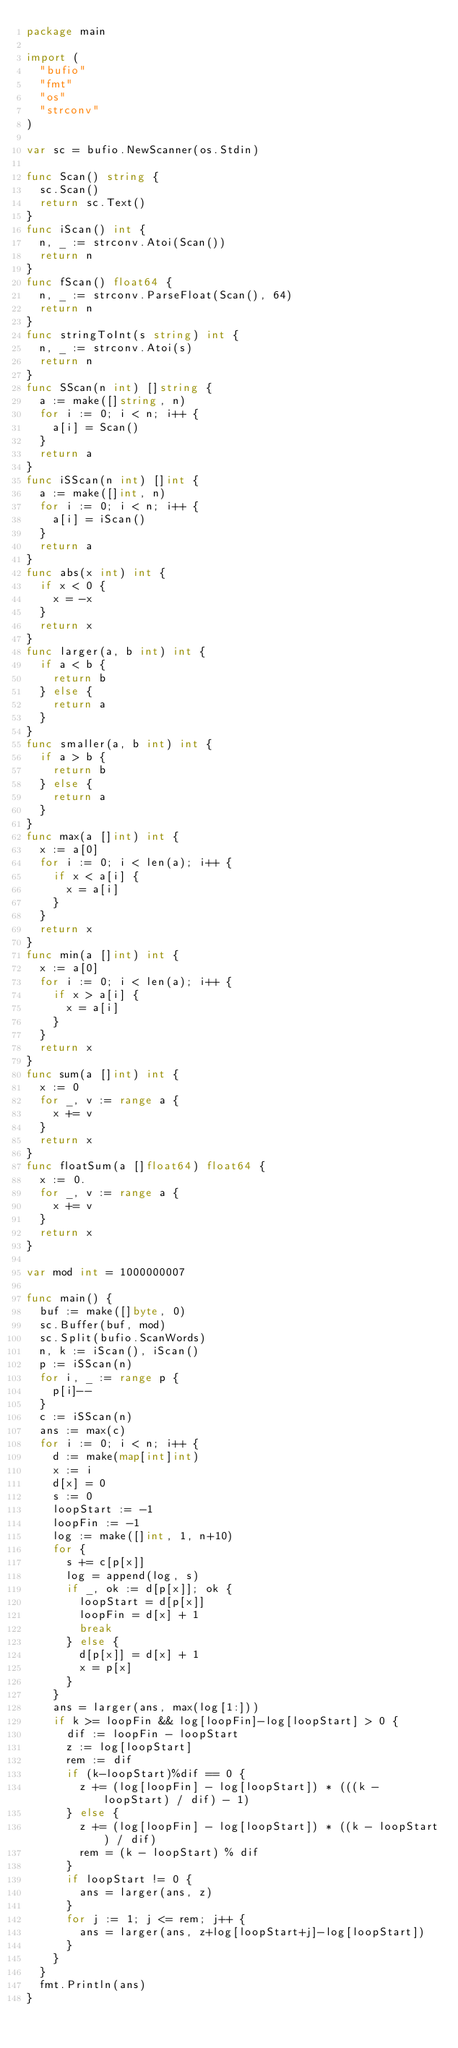<code> <loc_0><loc_0><loc_500><loc_500><_Go_>package main

import (
	"bufio"
	"fmt"
	"os"
	"strconv"
)

var sc = bufio.NewScanner(os.Stdin)

func Scan() string {
	sc.Scan()
	return sc.Text()
}
func iScan() int {
	n, _ := strconv.Atoi(Scan())
	return n
}
func fScan() float64 {
	n, _ := strconv.ParseFloat(Scan(), 64)
	return n
}
func stringToInt(s string) int {
	n, _ := strconv.Atoi(s)
	return n
}
func SScan(n int) []string {
	a := make([]string, n)
	for i := 0; i < n; i++ {
		a[i] = Scan()
	}
	return a
}
func iSScan(n int) []int {
	a := make([]int, n)
	for i := 0; i < n; i++ {
		a[i] = iScan()
	}
	return a
}
func abs(x int) int {
	if x < 0 {
		x = -x
	}
	return x
}
func larger(a, b int) int {
	if a < b {
		return b
	} else {
		return a
	}
}
func smaller(a, b int) int {
	if a > b {
		return b
	} else {
		return a
	}
}
func max(a []int) int {
	x := a[0]
	for i := 0; i < len(a); i++ {
		if x < a[i] {
			x = a[i]
		}
	}
	return x
}
func min(a []int) int {
	x := a[0]
	for i := 0; i < len(a); i++ {
		if x > a[i] {
			x = a[i]
		}
	}
	return x
}
func sum(a []int) int {
	x := 0
	for _, v := range a {
		x += v
	}
	return x
}
func floatSum(a []float64) float64 {
	x := 0.
	for _, v := range a {
		x += v
	}
	return x
}

var mod int = 1000000007

func main() {
	buf := make([]byte, 0)
	sc.Buffer(buf, mod)
	sc.Split(bufio.ScanWords)
	n, k := iScan(), iScan()
	p := iSScan(n)
	for i, _ := range p {
		p[i]--
	}
	c := iSScan(n)
	ans := max(c)
	for i := 0; i < n; i++ {
		d := make(map[int]int)
		x := i
		d[x] = 0
		s := 0
		loopStart := -1
		loopFin := -1
		log := make([]int, 1, n+10)
		for {
			s += c[p[x]]
			log = append(log, s)
			if _, ok := d[p[x]]; ok {
				loopStart = d[p[x]]
				loopFin = d[x] + 1
				break
			} else {
				d[p[x]] = d[x] + 1
				x = p[x]
			}
		}
		ans = larger(ans, max(log[1:]))
		if k >= loopFin && log[loopFin]-log[loopStart] > 0 {
			dif := loopFin - loopStart
			z := log[loopStart]
			rem := dif
			if (k-loopStart)%dif == 0 {
				z += (log[loopFin] - log[loopStart]) * (((k - loopStart) / dif) - 1)
			} else {
				z += (log[loopFin] - log[loopStart]) * ((k - loopStart) / dif)
				rem = (k - loopStart) % dif
			}
			if loopStart != 0 {
				ans = larger(ans, z)
			}
			for j := 1; j <= rem; j++ {
				ans = larger(ans, z+log[loopStart+j]-log[loopStart])
			}
		}
	}
	fmt.Println(ans)
}
</code> 